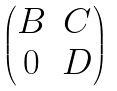<formula> <loc_0><loc_0><loc_500><loc_500>\begin{pmatrix} B & C \\ 0 & D \end{pmatrix}</formula> 